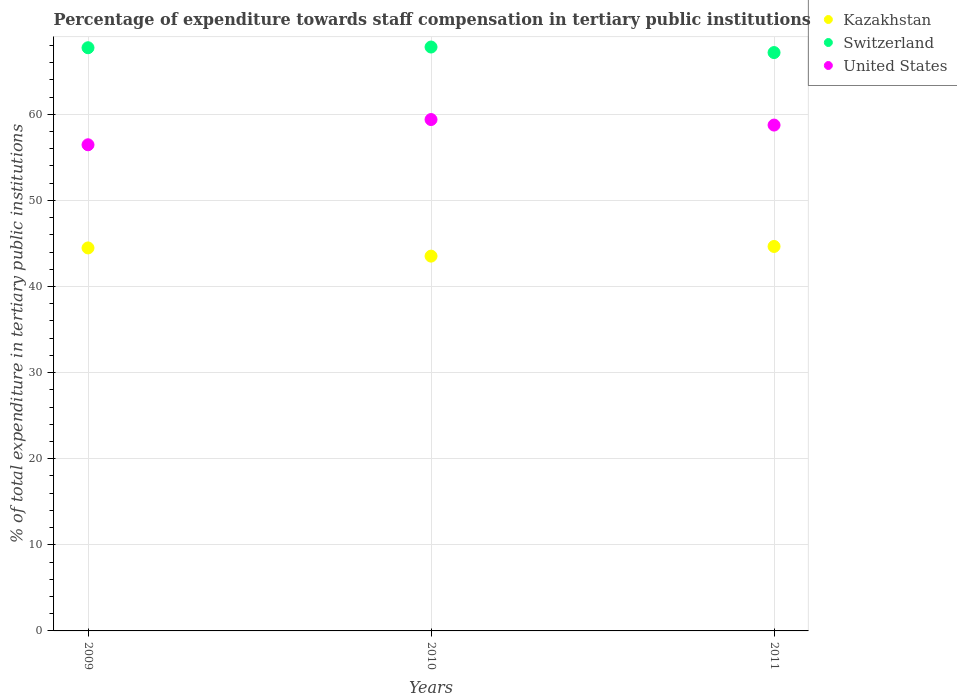How many different coloured dotlines are there?
Make the answer very short. 3. Is the number of dotlines equal to the number of legend labels?
Ensure brevity in your answer.  Yes. What is the percentage of expenditure towards staff compensation in Kazakhstan in 2011?
Provide a succinct answer. 44.65. Across all years, what is the maximum percentage of expenditure towards staff compensation in Kazakhstan?
Offer a terse response. 44.65. Across all years, what is the minimum percentage of expenditure towards staff compensation in Switzerland?
Offer a terse response. 67.16. In which year was the percentage of expenditure towards staff compensation in Kazakhstan maximum?
Offer a terse response. 2011. In which year was the percentage of expenditure towards staff compensation in Kazakhstan minimum?
Keep it short and to the point. 2010. What is the total percentage of expenditure towards staff compensation in United States in the graph?
Offer a very short reply. 174.59. What is the difference between the percentage of expenditure towards staff compensation in Kazakhstan in 2010 and that in 2011?
Offer a very short reply. -1.12. What is the difference between the percentage of expenditure towards staff compensation in Switzerland in 2009 and the percentage of expenditure towards staff compensation in Kazakhstan in 2010?
Your answer should be very brief. 24.2. What is the average percentage of expenditure towards staff compensation in United States per year?
Your answer should be very brief. 58.2. In the year 2010, what is the difference between the percentage of expenditure towards staff compensation in Switzerland and percentage of expenditure towards staff compensation in Kazakhstan?
Ensure brevity in your answer.  24.28. In how many years, is the percentage of expenditure towards staff compensation in United States greater than 20 %?
Make the answer very short. 3. What is the ratio of the percentage of expenditure towards staff compensation in United States in 2009 to that in 2011?
Your response must be concise. 0.96. Is the percentage of expenditure towards staff compensation in Kazakhstan in 2009 less than that in 2011?
Make the answer very short. Yes. Is the difference between the percentage of expenditure towards staff compensation in Switzerland in 2010 and 2011 greater than the difference between the percentage of expenditure towards staff compensation in Kazakhstan in 2010 and 2011?
Offer a very short reply. Yes. What is the difference between the highest and the second highest percentage of expenditure towards staff compensation in Kazakhstan?
Your answer should be compact. 0.17. What is the difference between the highest and the lowest percentage of expenditure towards staff compensation in Kazakhstan?
Make the answer very short. 1.12. In how many years, is the percentage of expenditure towards staff compensation in Switzerland greater than the average percentage of expenditure towards staff compensation in Switzerland taken over all years?
Ensure brevity in your answer.  2. Is the sum of the percentage of expenditure towards staff compensation in Kazakhstan in 2009 and 2011 greater than the maximum percentage of expenditure towards staff compensation in Switzerland across all years?
Provide a succinct answer. Yes. Does the percentage of expenditure towards staff compensation in United States monotonically increase over the years?
Keep it short and to the point. No. Is the percentage of expenditure towards staff compensation in Switzerland strictly greater than the percentage of expenditure towards staff compensation in Kazakhstan over the years?
Make the answer very short. Yes. Is the percentage of expenditure towards staff compensation in Kazakhstan strictly less than the percentage of expenditure towards staff compensation in Switzerland over the years?
Make the answer very short. Yes. How many dotlines are there?
Your answer should be very brief. 3. Does the graph contain grids?
Offer a very short reply. Yes. Where does the legend appear in the graph?
Provide a succinct answer. Top right. How many legend labels are there?
Ensure brevity in your answer.  3. How are the legend labels stacked?
Your answer should be compact. Vertical. What is the title of the graph?
Keep it short and to the point. Percentage of expenditure towards staff compensation in tertiary public institutions. Does "Switzerland" appear as one of the legend labels in the graph?
Your answer should be compact. Yes. What is the label or title of the Y-axis?
Your answer should be compact. % of total expenditure in tertiary public institutions. What is the % of total expenditure in tertiary public institutions of Kazakhstan in 2009?
Make the answer very short. 44.48. What is the % of total expenditure in tertiary public institutions in Switzerland in 2009?
Keep it short and to the point. 67.73. What is the % of total expenditure in tertiary public institutions of United States in 2009?
Make the answer very short. 56.46. What is the % of total expenditure in tertiary public institutions of Kazakhstan in 2010?
Provide a short and direct response. 43.52. What is the % of total expenditure in tertiary public institutions in Switzerland in 2010?
Give a very brief answer. 67.81. What is the % of total expenditure in tertiary public institutions of United States in 2010?
Offer a very short reply. 59.39. What is the % of total expenditure in tertiary public institutions in Kazakhstan in 2011?
Give a very brief answer. 44.65. What is the % of total expenditure in tertiary public institutions of Switzerland in 2011?
Offer a terse response. 67.16. What is the % of total expenditure in tertiary public institutions of United States in 2011?
Provide a short and direct response. 58.74. Across all years, what is the maximum % of total expenditure in tertiary public institutions in Kazakhstan?
Offer a very short reply. 44.65. Across all years, what is the maximum % of total expenditure in tertiary public institutions of Switzerland?
Make the answer very short. 67.81. Across all years, what is the maximum % of total expenditure in tertiary public institutions of United States?
Your answer should be very brief. 59.39. Across all years, what is the minimum % of total expenditure in tertiary public institutions in Kazakhstan?
Give a very brief answer. 43.52. Across all years, what is the minimum % of total expenditure in tertiary public institutions in Switzerland?
Keep it short and to the point. 67.16. Across all years, what is the minimum % of total expenditure in tertiary public institutions in United States?
Your response must be concise. 56.46. What is the total % of total expenditure in tertiary public institutions of Kazakhstan in the graph?
Give a very brief answer. 132.65. What is the total % of total expenditure in tertiary public institutions in Switzerland in the graph?
Make the answer very short. 202.7. What is the total % of total expenditure in tertiary public institutions in United States in the graph?
Offer a very short reply. 174.59. What is the difference between the % of total expenditure in tertiary public institutions of Kazakhstan in 2009 and that in 2010?
Ensure brevity in your answer.  0.95. What is the difference between the % of total expenditure in tertiary public institutions of Switzerland in 2009 and that in 2010?
Your response must be concise. -0.08. What is the difference between the % of total expenditure in tertiary public institutions in United States in 2009 and that in 2010?
Make the answer very short. -2.93. What is the difference between the % of total expenditure in tertiary public institutions of Kazakhstan in 2009 and that in 2011?
Provide a succinct answer. -0.17. What is the difference between the % of total expenditure in tertiary public institutions of Switzerland in 2009 and that in 2011?
Offer a very short reply. 0.56. What is the difference between the % of total expenditure in tertiary public institutions in United States in 2009 and that in 2011?
Give a very brief answer. -2.29. What is the difference between the % of total expenditure in tertiary public institutions in Kazakhstan in 2010 and that in 2011?
Your answer should be compact. -1.12. What is the difference between the % of total expenditure in tertiary public institutions of Switzerland in 2010 and that in 2011?
Your answer should be very brief. 0.64. What is the difference between the % of total expenditure in tertiary public institutions in United States in 2010 and that in 2011?
Your response must be concise. 0.64. What is the difference between the % of total expenditure in tertiary public institutions of Kazakhstan in 2009 and the % of total expenditure in tertiary public institutions of Switzerland in 2010?
Provide a short and direct response. -23.33. What is the difference between the % of total expenditure in tertiary public institutions in Kazakhstan in 2009 and the % of total expenditure in tertiary public institutions in United States in 2010?
Provide a short and direct response. -14.91. What is the difference between the % of total expenditure in tertiary public institutions in Switzerland in 2009 and the % of total expenditure in tertiary public institutions in United States in 2010?
Your answer should be compact. 8.34. What is the difference between the % of total expenditure in tertiary public institutions in Kazakhstan in 2009 and the % of total expenditure in tertiary public institutions in Switzerland in 2011?
Give a very brief answer. -22.69. What is the difference between the % of total expenditure in tertiary public institutions of Kazakhstan in 2009 and the % of total expenditure in tertiary public institutions of United States in 2011?
Ensure brevity in your answer.  -14.27. What is the difference between the % of total expenditure in tertiary public institutions of Switzerland in 2009 and the % of total expenditure in tertiary public institutions of United States in 2011?
Make the answer very short. 8.98. What is the difference between the % of total expenditure in tertiary public institutions in Kazakhstan in 2010 and the % of total expenditure in tertiary public institutions in Switzerland in 2011?
Keep it short and to the point. -23.64. What is the difference between the % of total expenditure in tertiary public institutions in Kazakhstan in 2010 and the % of total expenditure in tertiary public institutions in United States in 2011?
Make the answer very short. -15.22. What is the difference between the % of total expenditure in tertiary public institutions of Switzerland in 2010 and the % of total expenditure in tertiary public institutions of United States in 2011?
Provide a short and direct response. 9.06. What is the average % of total expenditure in tertiary public institutions in Kazakhstan per year?
Make the answer very short. 44.22. What is the average % of total expenditure in tertiary public institutions in Switzerland per year?
Offer a terse response. 67.57. What is the average % of total expenditure in tertiary public institutions of United States per year?
Keep it short and to the point. 58.2. In the year 2009, what is the difference between the % of total expenditure in tertiary public institutions of Kazakhstan and % of total expenditure in tertiary public institutions of Switzerland?
Give a very brief answer. -23.25. In the year 2009, what is the difference between the % of total expenditure in tertiary public institutions in Kazakhstan and % of total expenditure in tertiary public institutions in United States?
Offer a very short reply. -11.98. In the year 2009, what is the difference between the % of total expenditure in tertiary public institutions of Switzerland and % of total expenditure in tertiary public institutions of United States?
Your answer should be very brief. 11.27. In the year 2010, what is the difference between the % of total expenditure in tertiary public institutions in Kazakhstan and % of total expenditure in tertiary public institutions in Switzerland?
Keep it short and to the point. -24.28. In the year 2010, what is the difference between the % of total expenditure in tertiary public institutions in Kazakhstan and % of total expenditure in tertiary public institutions in United States?
Your response must be concise. -15.86. In the year 2010, what is the difference between the % of total expenditure in tertiary public institutions in Switzerland and % of total expenditure in tertiary public institutions in United States?
Your answer should be compact. 8.42. In the year 2011, what is the difference between the % of total expenditure in tertiary public institutions in Kazakhstan and % of total expenditure in tertiary public institutions in Switzerland?
Your answer should be compact. -22.52. In the year 2011, what is the difference between the % of total expenditure in tertiary public institutions of Kazakhstan and % of total expenditure in tertiary public institutions of United States?
Keep it short and to the point. -14.1. In the year 2011, what is the difference between the % of total expenditure in tertiary public institutions of Switzerland and % of total expenditure in tertiary public institutions of United States?
Provide a succinct answer. 8.42. What is the ratio of the % of total expenditure in tertiary public institutions in Kazakhstan in 2009 to that in 2010?
Give a very brief answer. 1.02. What is the ratio of the % of total expenditure in tertiary public institutions of Switzerland in 2009 to that in 2010?
Offer a very short reply. 1. What is the ratio of the % of total expenditure in tertiary public institutions of United States in 2009 to that in 2010?
Your answer should be compact. 0.95. What is the ratio of the % of total expenditure in tertiary public institutions in Switzerland in 2009 to that in 2011?
Give a very brief answer. 1.01. What is the ratio of the % of total expenditure in tertiary public institutions in United States in 2009 to that in 2011?
Your answer should be very brief. 0.96. What is the ratio of the % of total expenditure in tertiary public institutions of Kazakhstan in 2010 to that in 2011?
Provide a succinct answer. 0.97. What is the ratio of the % of total expenditure in tertiary public institutions in Switzerland in 2010 to that in 2011?
Keep it short and to the point. 1.01. What is the ratio of the % of total expenditure in tertiary public institutions in United States in 2010 to that in 2011?
Make the answer very short. 1.01. What is the difference between the highest and the second highest % of total expenditure in tertiary public institutions of Kazakhstan?
Offer a very short reply. 0.17. What is the difference between the highest and the second highest % of total expenditure in tertiary public institutions in Switzerland?
Your answer should be very brief. 0.08. What is the difference between the highest and the second highest % of total expenditure in tertiary public institutions in United States?
Your answer should be very brief. 0.64. What is the difference between the highest and the lowest % of total expenditure in tertiary public institutions of Kazakhstan?
Make the answer very short. 1.12. What is the difference between the highest and the lowest % of total expenditure in tertiary public institutions in Switzerland?
Make the answer very short. 0.64. What is the difference between the highest and the lowest % of total expenditure in tertiary public institutions in United States?
Your response must be concise. 2.93. 